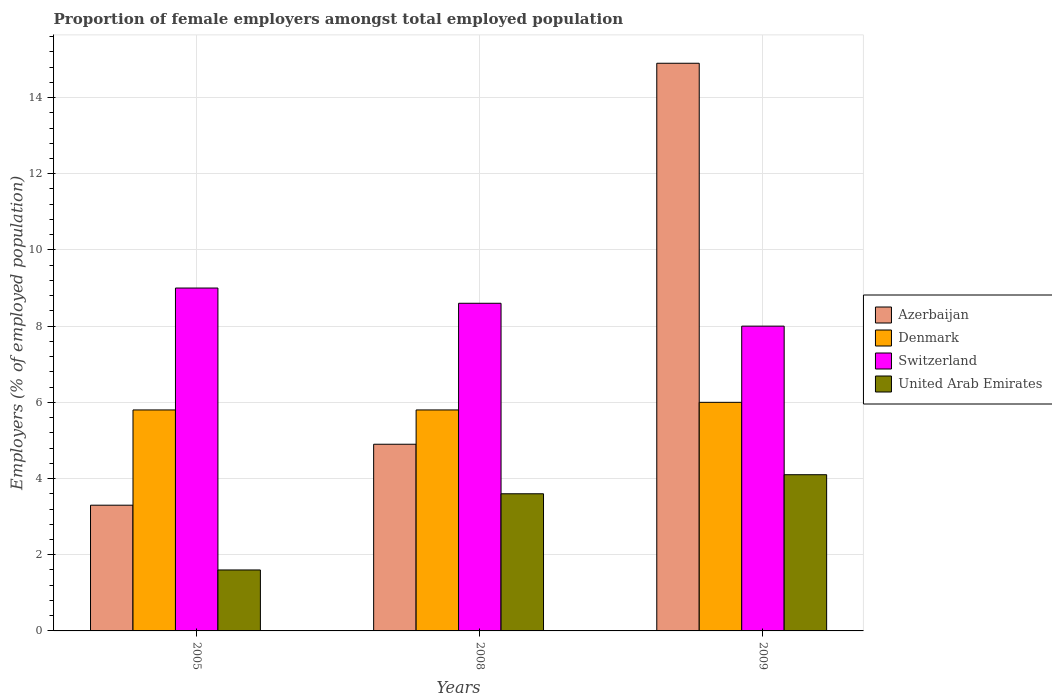How many different coloured bars are there?
Your answer should be very brief. 4. How many groups of bars are there?
Keep it short and to the point. 3. How many bars are there on the 1st tick from the left?
Your answer should be very brief. 4. How many bars are there on the 1st tick from the right?
Your answer should be compact. 4. What is the proportion of female employers in United Arab Emirates in 2005?
Keep it short and to the point. 1.6. Across all years, what is the minimum proportion of female employers in Azerbaijan?
Provide a succinct answer. 3.3. In which year was the proportion of female employers in United Arab Emirates maximum?
Provide a short and direct response. 2009. In which year was the proportion of female employers in Azerbaijan minimum?
Keep it short and to the point. 2005. What is the total proportion of female employers in United Arab Emirates in the graph?
Give a very brief answer. 9.3. What is the difference between the proportion of female employers in United Arab Emirates in 2005 and that in 2008?
Provide a short and direct response. -2. What is the difference between the proportion of female employers in Denmark in 2008 and the proportion of female employers in Azerbaijan in 2009?
Your answer should be compact. -9.1. What is the average proportion of female employers in Denmark per year?
Offer a terse response. 5.87. In the year 2005, what is the difference between the proportion of female employers in Denmark and proportion of female employers in United Arab Emirates?
Your answer should be compact. 4.2. Is the proportion of female employers in Azerbaijan in 2008 less than that in 2009?
Keep it short and to the point. Yes. What is the difference between the highest and the second highest proportion of female employers in Switzerland?
Give a very brief answer. 0.4. What is the difference between the highest and the lowest proportion of female employers in United Arab Emirates?
Your answer should be compact. 2.5. In how many years, is the proportion of female employers in Denmark greater than the average proportion of female employers in Denmark taken over all years?
Give a very brief answer. 1. Is the sum of the proportion of female employers in Switzerland in 2005 and 2008 greater than the maximum proportion of female employers in Denmark across all years?
Offer a very short reply. Yes. Is it the case that in every year, the sum of the proportion of female employers in Azerbaijan and proportion of female employers in Switzerland is greater than the sum of proportion of female employers in Denmark and proportion of female employers in United Arab Emirates?
Provide a short and direct response. Yes. What does the 4th bar from the left in 2008 represents?
Your answer should be very brief. United Arab Emirates. What does the 1st bar from the right in 2005 represents?
Your answer should be very brief. United Arab Emirates. Is it the case that in every year, the sum of the proportion of female employers in United Arab Emirates and proportion of female employers in Switzerland is greater than the proportion of female employers in Azerbaijan?
Your response must be concise. No. How many bars are there?
Keep it short and to the point. 12. Are all the bars in the graph horizontal?
Give a very brief answer. No. Does the graph contain grids?
Give a very brief answer. Yes. How many legend labels are there?
Your response must be concise. 4. What is the title of the graph?
Keep it short and to the point. Proportion of female employers amongst total employed population. What is the label or title of the Y-axis?
Provide a succinct answer. Employers (% of employed population). What is the Employers (% of employed population) in Azerbaijan in 2005?
Make the answer very short. 3.3. What is the Employers (% of employed population) in Denmark in 2005?
Provide a short and direct response. 5.8. What is the Employers (% of employed population) of Switzerland in 2005?
Ensure brevity in your answer.  9. What is the Employers (% of employed population) in United Arab Emirates in 2005?
Your answer should be compact. 1.6. What is the Employers (% of employed population) of Azerbaijan in 2008?
Provide a short and direct response. 4.9. What is the Employers (% of employed population) of Denmark in 2008?
Provide a succinct answer. 5.8. What is the Employers (% of employed population) of Switzerland in 2008?
Ensure brevity in your answer.  8.6. What is the Employers (% of employed population) of United Arab Emirates in 2008?
Your answer should be very brief. 3.6. What is the Employers (% of employed population) of Azerbaijan in 2009?
Your answer should be very brief. 14.9. What is the Employers (% of employed population) of Denmark in 2009?
Your answer should be very brief. 6. What is the Employers (% of employed population) of Switzerland in 2009?
Keep it short and to the point. 8. What is the Employers (% of employed population) of United Arab Emirates in 2009?
Provide a succinct answer. 4.1. Across all years, what is the maximum Employers (% of employed population) of Azerbaijan?
Ensure brevity in your answer.  14.9. Across all years, what is the maximum Employers (% of employed population) of Denmark?
Offer a terse response. 6. Across all years, what is the maximum Employers (% of employed population) in United Arab Emirates?
Provide a short and direct response. 4.1. Across all years, what is the minimum Employers (% of employed population) in Azerbaijan?
Keep it short and to the point. 3.3. Across all years, what is the minimum Employers (% of employed population) in Denmark?
Provide a succinct answer. 5.8. Across all years, what is the minimum Employers (% of employed population) in United Arab Emirates?
Provide a short and direct response. 1.6. What is the total Employers (% of employed population) in Azerbaijan in the graph?
Your answer should be compact. 23.1. What is the total Employers (% of employed population) of Denmark in the graph?
Provide a short and direct response. 17.6. What is the total Employers (% of employed population) of Switzerland in the graph?
Your answer should be very brief. 25.6. What is the difference between the Employers (% of employed population) in Denmark in 2005 and that in 2008?
Offer a terse response. 0. What is the difference between the Employers (% of employed population) in Denmark in 2005 and that in 2009?
Ensure brevity in your answer.  -0.2. What is the difference between the Employers (% of employed population) in Azerbaijan in 2008 and that in 2009?
Keep it short and to the point. -10. What is the difference between the Employers (% of employed population) in Denmark in 2008 and that in 2009?
Provide a succinct answer. -0.2. What is the difference between the Employers (% of employed population) in United Arab Emirates in 2008 and that in 2009?
Your response must be concise. -0.5. What is the difference between the Employers (% of employed population) in Azerbaijan in 2005 and the Employers (% of employed population) in Denmark in 2008?
Offer a terse response. -2.5. What is the difference between the Employers (% of employed population) in Azerbaijan in 2005 and the Employers (% of employed population) in Switzerland in 2008?
Your answer should be very brief. -5.3. What is the difference between the Employers (% of employed population) of Azerbaijan in 2005 and the Employers (% of employed population) of United Arab Emirates in 2008?
Make the answer very short. -0.3. What is the difference between the Employers (% of employed population) in Denmark in 2005 and the Employers (% of employed population) in Switzerland in 2008?
Ensure brevity in your answer.  -2.8. What is the difference between the Employers (% of employed population) of Azerbaijan in 2005 and the Employers (% of employed population) of Switzerland in 2009?
Your answer should be very brief. -4.7. What is the difference between the Employers (% of employed population) of Azerbaijan in 2005 and the Employers (% of employed population) of United Arab Emirates in 2009?
Your answer should be compact. -0.8. What is the difference between the Employers (% of employed population) of Azerbaijan in 2008 and the Employers (% of employed population) of Denmark in 2009?
Give a very brief answer. -1.1. What is the average Employers (% of employed population) in Azerbaijan per year?
Ensure brevity in your answer.  7.7. What is the average Employers (% of employed population) of Denmark per year?
Ensure brevity in your answer.  5.87. What is the average Employers (% of employed population) of Switzerland per year?
Offer a terse response. 8.53. In the year 2008, what is the difference between the Employers (% of employed population) of Azerbaijan and Employers (% of employed population) of United Arab Emirates?
Give a very brief answer. 1.3. In the year 2009, what is the difference between the Employers (% of employed population) of Azerbaijan and Employers (% of employed population) of Denmark?
Your answer should be compact. 8.9. In the year 2009, what is the difference between the Employers (% of employed population) in Denmark and Employers (% of employed population) in Switzerland?
Offer a terse response. -2. What is the ratio of the Employers (% of employed population) of Azerbaijan in 2005 to that in 2008?
Provide a succinct answer. 0.67. What is the ratio of the Employers (% of employed population) of Denmark in 2005 to that in 2008?
Your answer should be compact. 1. What is the ratio of the Employers (% of employed population) of Switzerland in 2005 to that in 2008?
Provide a succinct answer. 1.05. What is the ratio of the Employers (% of employed population) in United Arab Emirates in 2005 to that in 2008?
Keep it short and to the point. 0.44. What is the ratio of the Employers (% of employed population) of Azerbaijan in 2005 to that in 2009?
Give a very brief answer. 0.22. What is the ratio of the Employers (% of employed population) of Denmark in 2005 to that in 2009?
Your answer should be very brief. 0.97. What is the ratio of the Employers (% of employed population) of United Arab Emirates in 2005 to that in 2009?
Keep it short and to the point. 0.39. What is the ratio of the Employers (% of employed population) in Azerbaijan in 2008 to that in 2009?
Give a very brief answer. 0.33. What is the ratio of the Employers (% of employed population) of Denmark in 2008 to that in 2009?
Offer a terse response. 0.97. What is the ratio of the Employers (% of employed population) of Switzerland in 2008 to that in 2009?
Offer a very short reply. 1.07. What is the ratio of the Employers (% of employed population) in United Arab Emirates in 2008 to that in 2009?
Your answer should be compact. 0.88. What is the difference between the highest and the second highest Employers (% of employed population) in Azerbaijan?
Give a very brief answer. 10. What is the difference between the highest and the second highest Employers (% of employed population) of Switzerland?
Your answer should be compact. 0.4. What is the difference between the highest and the second highest Employers (% of employed population) in United Arab Emirates?
Your response must be concise. 0.5. What is the difference between the highest and the lowest Employers (% of employed population) in Switzerland?
Provide a short and direct response. 1. 